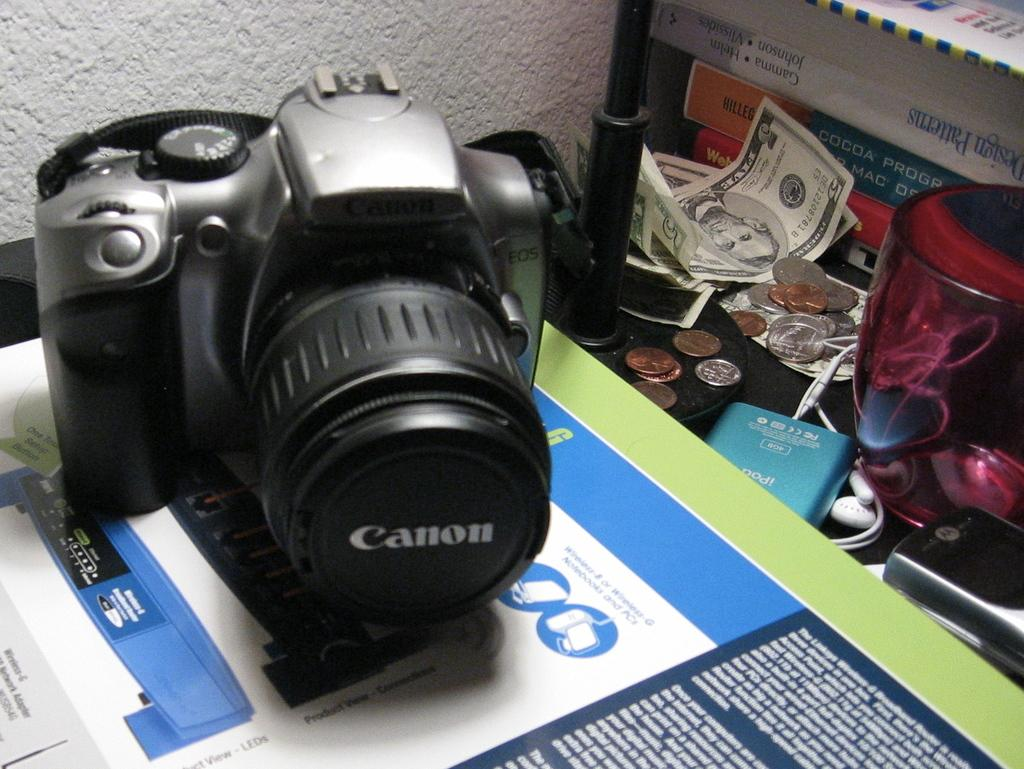What device is located on the left side of the image? There is a camera on the left side of the image. What small, round objects can be seen in the image? There are coins in the image. What type of audio accessory is visible in the image? Earphones are visible in the image. What type of communication device is present in the image? There is a mobile in the image. What type of written material is present in the image? There are papers and books in the image. What other unspecified objects can be seen on the right side of the image? There are other unspecified objects in the image on the right side. How does the brother run in the image? There is no brother or running depicted in the image. What effect does the camera have on the books in the image? The camera does not have any effect on the books in the image; they are separate objects. 